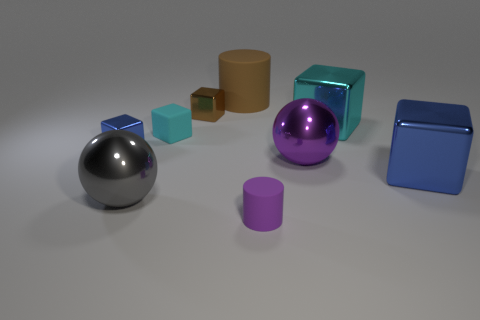How many cyan cubes must be subtracted to get 1 cyan cubes? 1 Subtract all brown cubes. How many cubes are left? 4 Subtract all tiny cyan cubes. How many cubes are left? 4 Subtract all yellow blocks. Subtract all cyan cylinders. How many blocks are left? 5 Add 1 balls. How many objects exist? 10 Subtract all cylinders. How many objects are left? 7 Subtract all brown cylinders. Subtract all large purple metallic things. How many objects are left? 7 Add 3 large spheres. How many large spheres are left? 5 Add 9 big cyan metal cubes. How many big cyan metal cubes exist? 10 Subtract 0 cyan cylinders. How many objects are left? 9 